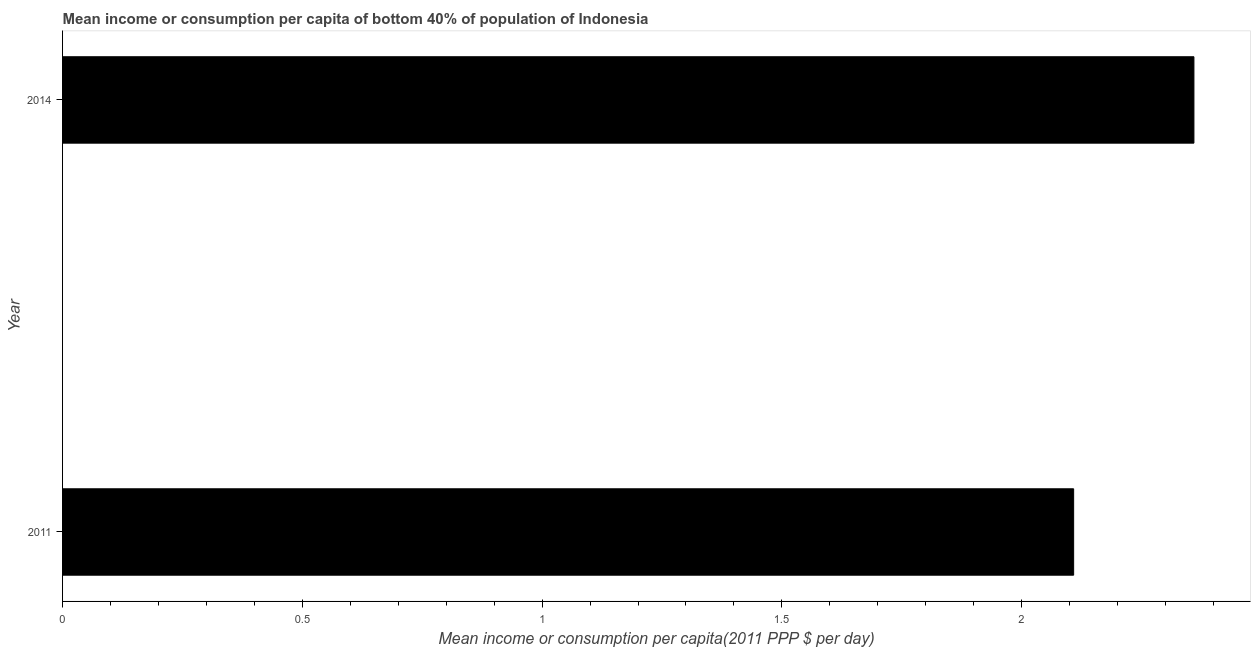Does the graph contain any zero values?
Your answer should be very brief. No. Does the graph contain grids?
Make the answer very short. No. What is the title of the graph?
Provide a short and direct response. Mean income or consumption per capita of bottom 40% of population of Indonesia. What is the label or title of the X-axis?
Ensure brevity in your answer.  Mean income or consumption per capita(2011 PPP $ per day). What is the label or title of the Y-axis?
Provide a short and direct response. Year. What is the mean income or consumption in 2014?
Make the answer very short. 2.36. Across all years, what is the maximum mean income or consumption?
Provide a short and direct response. 2.36. Across all years, what is the minimum mean income or consumption?
Give a very brief answer. 2.11. In which year was the mean income or consumption maximum?
Your response must be concise. 2014. In which year was the mean income or consumption minimum?
Your response must be concise. 2011. What is the sum of the mean income or consumption?
Give a very brief answer. 4.47. What is the difference between the mean income or consumption in 2011 and 2014?
Give a very brief answer. -0.25. What is the average mean income or consumption per year?
Your answer should be compact. 2.23. What is the median mean income or consumption?
Offer a very short reply. 2.23. In how many years, is the mean income or consumption greater than 0.5 $?
Your answer should be compact. 2. Do a majority of the years between 2014 and 2011 (inclusive) have mean income or consumption greater than 1.9 $?
Keep it short and to the point. No. What is the ratio of the mean income or consumption in 2011 to that in 2014?
Ensure brevity in your answer.  0.89. Is the mean income or consumption in 2011 less than that in 2014?
Ensure brevity in your answer.  Yes. How many years are there in the graph?
Your answer should be compact. 2. What is the difference between two consecutive major ticks on the X-axis?
Give a very brief answer. 0.5. Are the values on the major ticks of X-axis written in scientific E-notation?
Offer a very short reply. No. What is the Mean income or consumption per capita(2011 PPP $ per day) in 2011?
Provide a short and direct response. 2.11. What is the Mean income or consumption per capita(2011 PPP $ per day) in 2014?
Keep it short and to the point. 2.36. What is the difference between the Mean income or consumption per capita(2011 PPP $ per day) in 2011 and 2014?
Provide a succinct answer. -0.25. What is the ratio of the Mean income or consumption per capita(2011 PPP $ per day) in 2011 to that in 2014?
Keep it short and to the point. 0.89. 